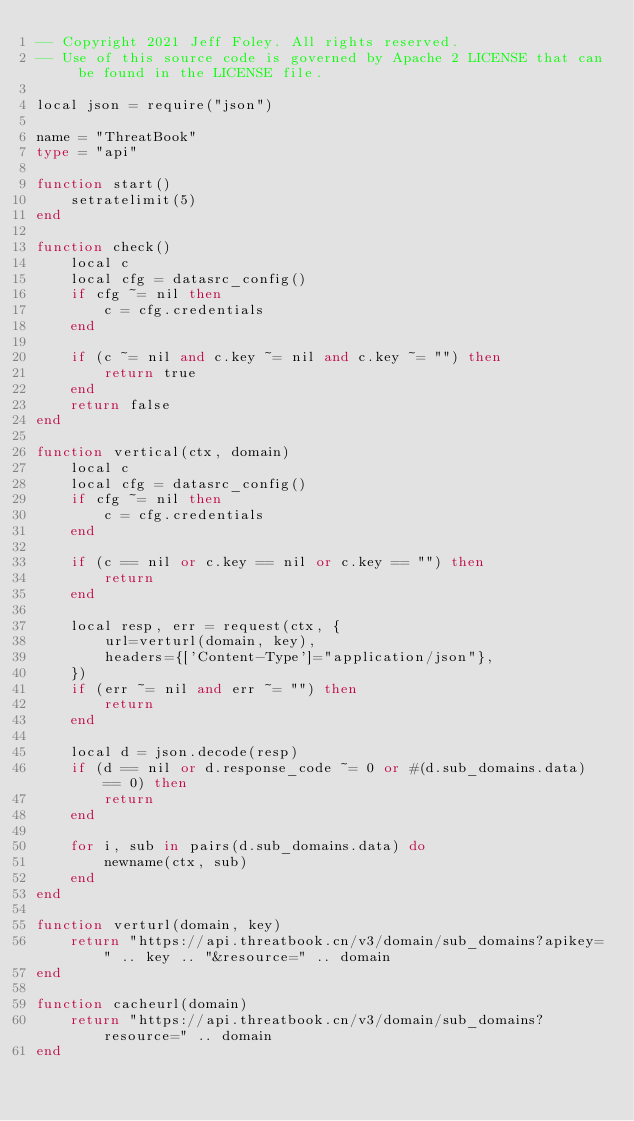<code> <loc_0><loc_0><loc_500><loc_500><_Ada_>-- Copyright 2021 Jeff Foley. All rights reserved.
-- Use of this source code is governed by Apache 2 LICENSE that can be found in the LICENSE file.

local json = require("json")

name = "ThreatBook"
type = "api"

function start()
    setratelimit(5)
end

function check()
    local c
    local cfg = datasrc_config()
    if cfg ~= nil then
        c = cfg.credentials
    end

    if (c ~= nil and c.key ~= nil and c.key ~= "") then
        return true
    end
    return false
end

function vertical(ctx, domain)
    local c
    local cfg = datasrc_config()
    if cfg ~= nil then
        c = cfg.credentials
    end

    if (c == nil or c.key == nil or c.key == "") then
        return
    end

    local resp, err = request(ctx, {
        url=verturl(domain, key),
        headers={['Content-Type']="application/json"},
    })
    if (err ~= nil and err ~= "") then
        return
    end

    local d = json.decode(resp)
    if (d == nil or d.response_code ~= 0 or #(d.sub_domains.data) == 0) then
        return
    end

    for i, sub in pairs(d.sub_domains.data) do
        newname(ctx, sub)
    end
end

function verturl(domain, key)
    return "https://api.threatbook.cn/v3/domain/sub_domains?apikey=" .. key .. "&resource=" .. domain
end

function cacheurl(domain)
    return "https://api.threatbook.cn/v3/domain/sub_domains?resource=" .. domain
end
</code> 